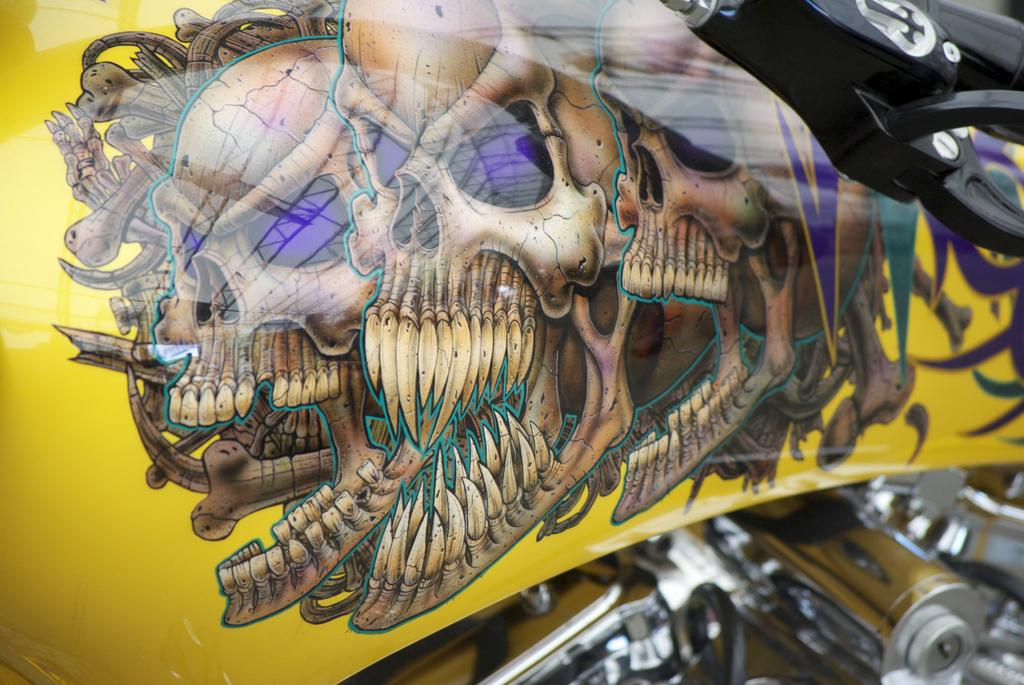What is the main subject of the image? The main subject of the image is a bike. What design elements are present on the bike? The bike has skull designs. Can you describe the visible parts of the bike? There are visible parts of the bike, including a handle. What type of approval does the woman in the image give to the bike? There is no woman present in the image, so it is not possible to determine any approval given. 